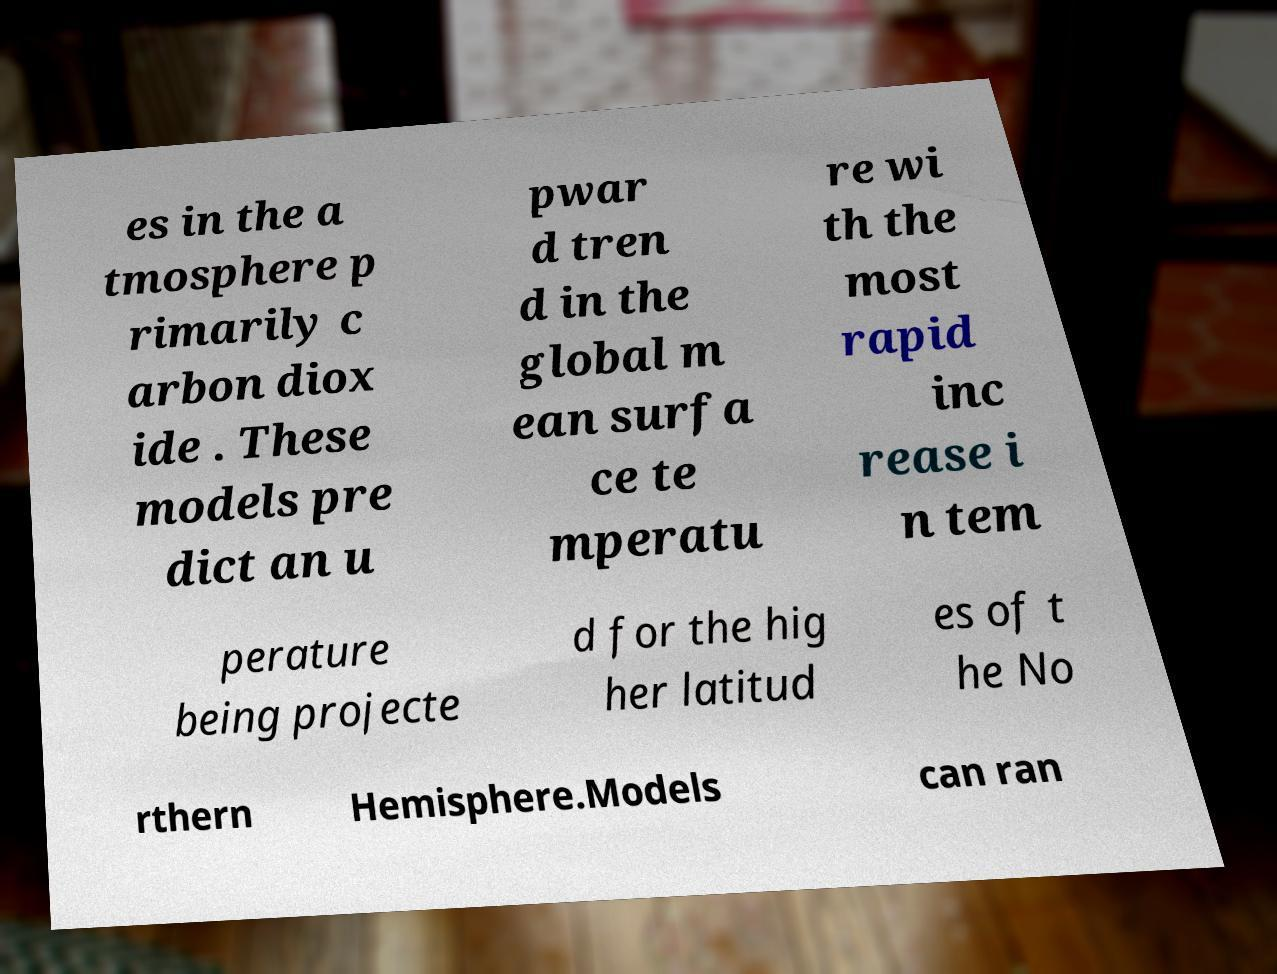What messages or text are displayed in this image? I need them in a readable, typed format. es in the a tmosphere p rimarily c arbon diox ide . These models pre dict an u pwar d tren d in the global m ean surfa ce te mperatu re wi th the most rapid inc rease i n tem perature being projecte d for the hig her latitud es of t he No rthern Hemisphere.Models can ran 